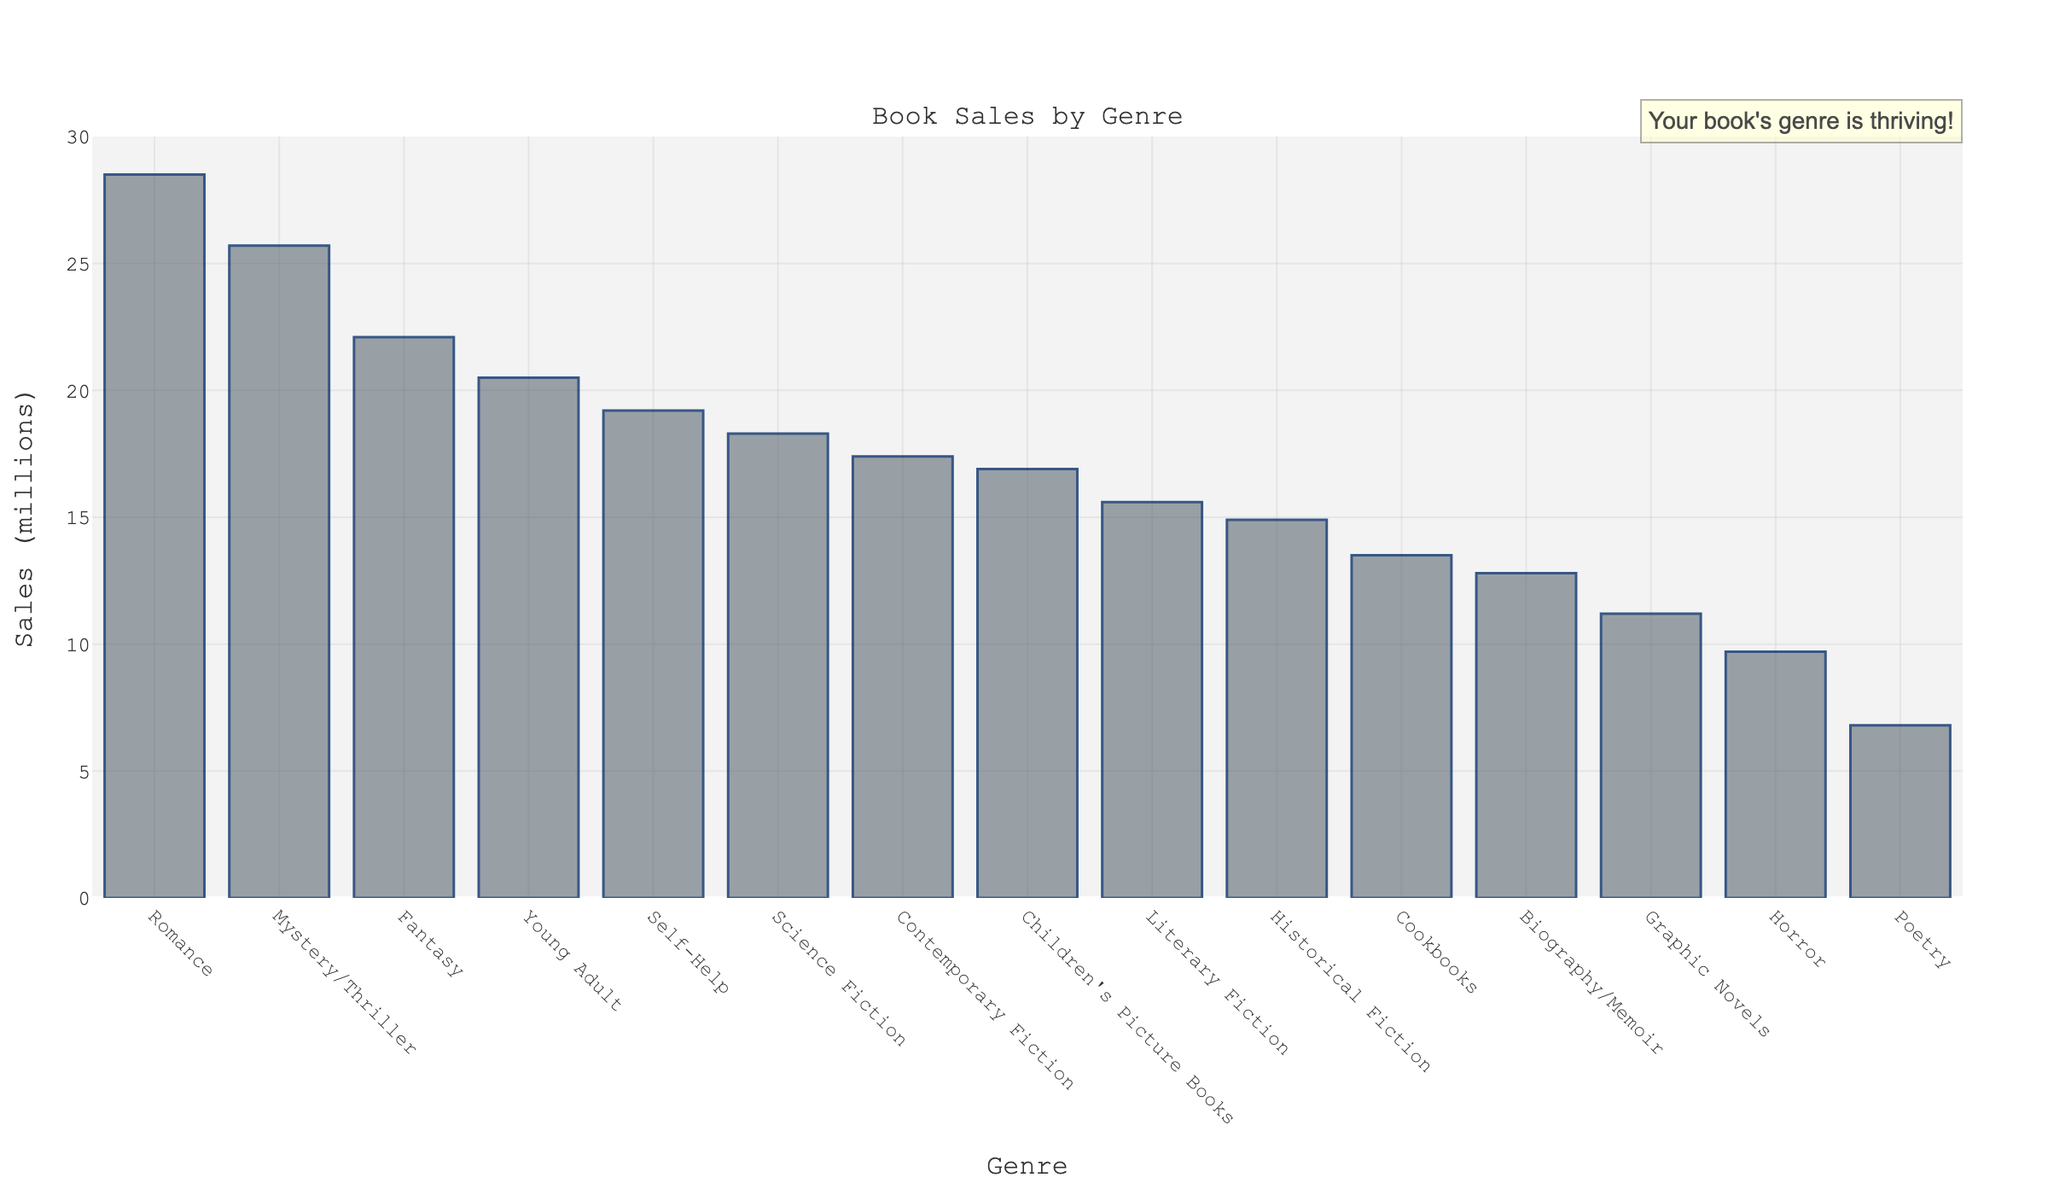Which genre has the highest book sales? The figure shows a bar chart with the heights of the bars representing sales. The tallest bar belongs to the "Romance" genre.
Answer: Romance How much more book sales does the Romance genre have compared to Mystery/Thriller? The Romance genre has sales of 28.5 million, while Mystery/Thriller has 25.7 million. The difference is calculated as 28.5 - 25.7.
Answer: 2.8 million What is the combined sales for Fantasy and Science Fiction genres? The sales for Fantasy are 22.1 million and for Science Fiction are 18.3 million. Their combined sales are 22.1 + 18.3.
Answer: 40.4 million Which genre has the lowest book sales? The figure shows a bar chart with the heights of the bars representing sales. The shortest bar belongs to the "Poetry" genre.
Answer: Poetry Which genres have higher sales than Self-Help? Self-Help has sales of 19.2 million. The genres with higher sales are Romance (28.5 million), Mystery/Thriller (25.7 million), Fantasy (22.1 million), and Young Adult (20.5 million).
Answer: Romance, Mystery/Thriller, Fantasy, Young Adult How much more book sales do Children's Picture Books have compared to Poetry? Children's Picture Books have sales of 16.9 million, while Poetry has 6.8 million. The difference is 16.9 - 6.8.
Answer: 10.1 million Compare the sales of Cookbooks and Historical Fiction genres. Which one has higher sales? Cookbooks have sales of 13.5 million and Historical Fiction has 14.9 million. Historical Fiction has higher sales.
Answer: Historical Fiction What is the average sales of Science Fiction, Fantasy, and Young Adult genres? Add the sales of Science Fiction (18.3 million), Fantasy (22.1 million), and Young Adult (20.5 million), then divide the sum by 3. (18.3 + 22.1 + 20.5)/3
Answer: 20.3 million Which genre has sales closest to the median sales value? Arrange the sales values in ascending order and find the median value. The genre closest to this value is identified. The median value is 17.4 million, which belongs to Contemporary Fiction
Answer: Contemporary Fiction 